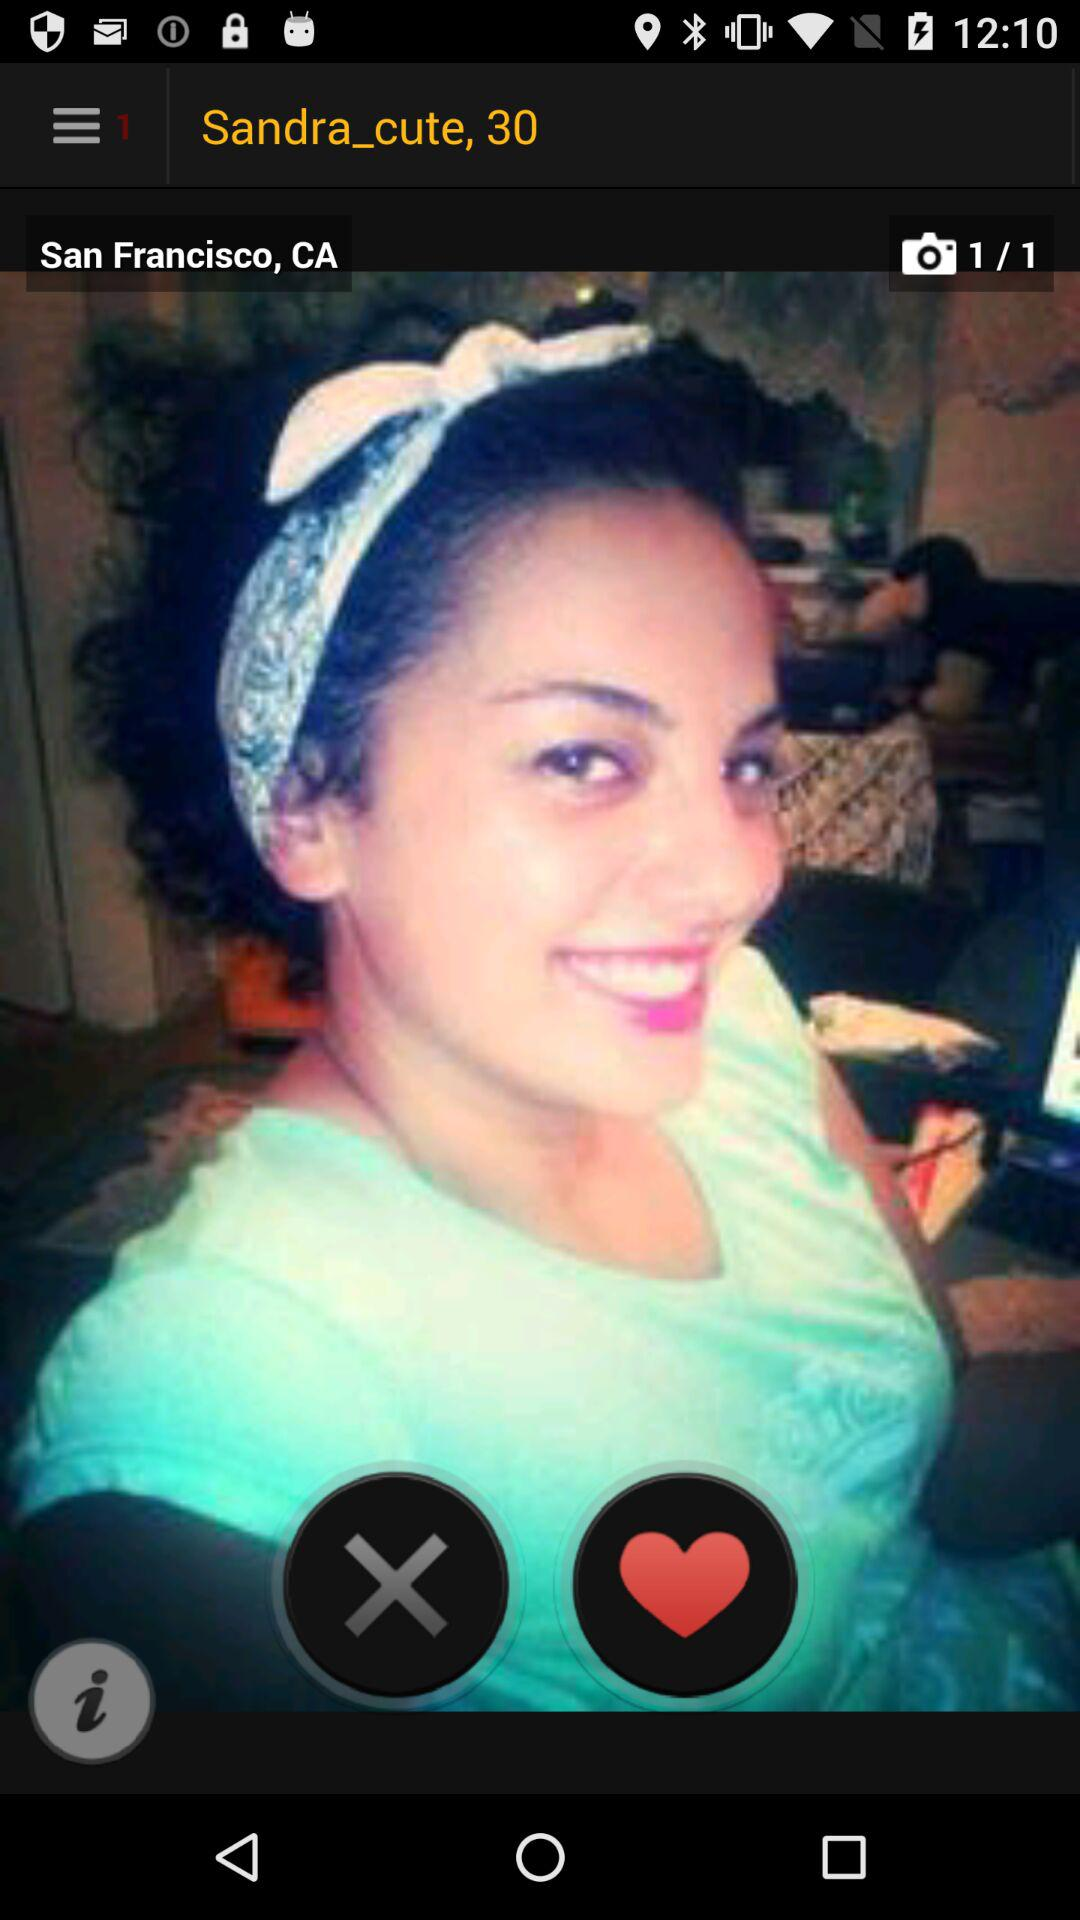What is the total number of photos? The total number of photos is 1. 